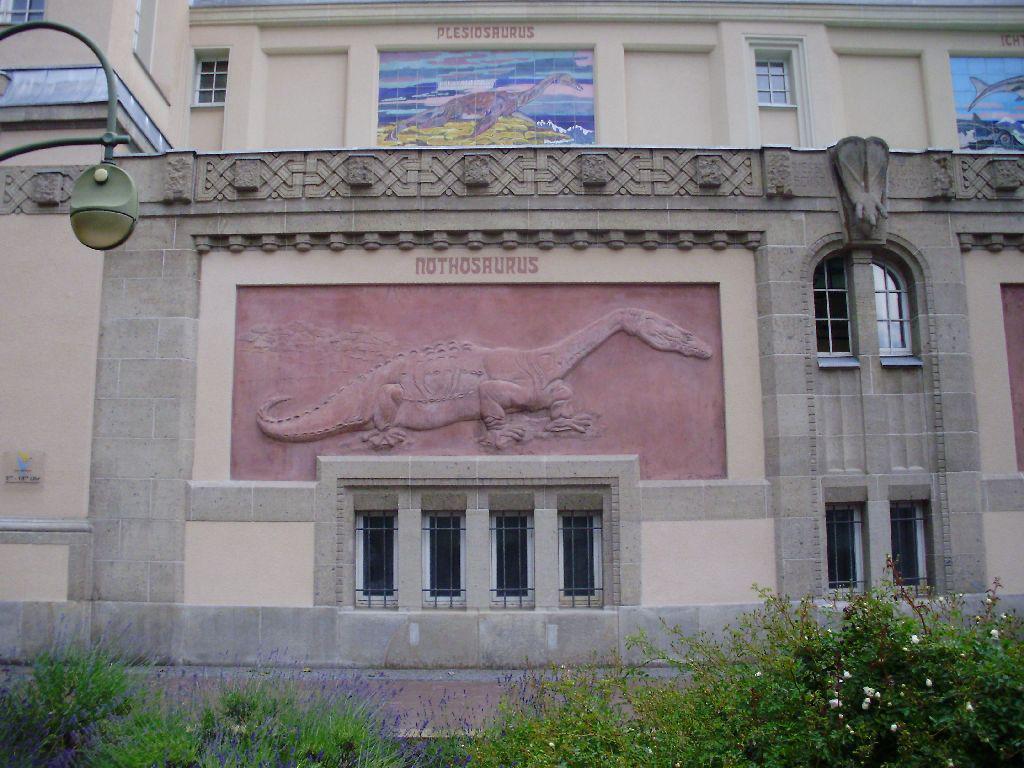Could you give a brief overview of what you see in this image? In this picture, there is a building with windows, painting and dinosaurs structures. Towards the left, there is a light. At the bottom, there are plants. 